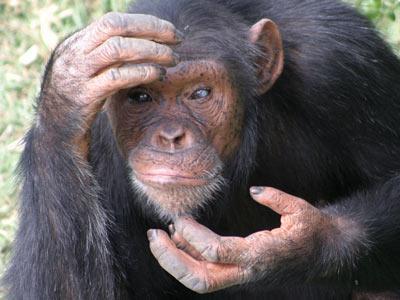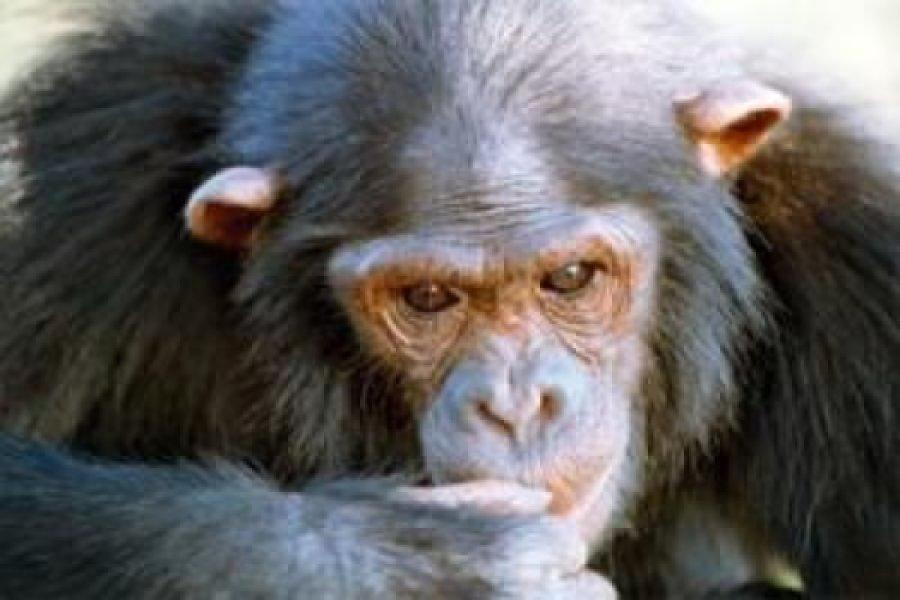The first image is the image on the left, the second image is the image on the right. Examine the images to the left and right. Is the description "There is at most 1 black monkey with its mouth open." accurate? Answer yes or no. No. The first image is the image on the left, the second image is the image on the right. Examine the images to the left and right. Is the description "one chimp has its mouth open wide" accurate? Answer yes or no. No. 